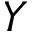Convert formula to latex. <formula><loc_0><loc_0><loc_500><loc_500>Y</formula> 